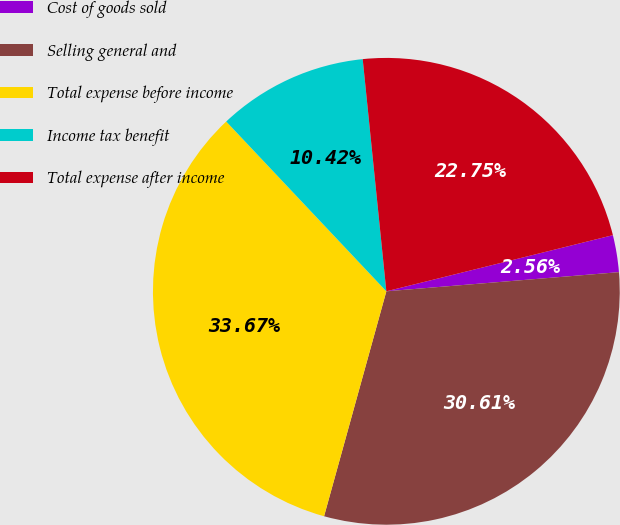Convert chart to OTSL. <chart><loc_0><loc_0><loc_500><loc_500><pie_chart><fcel>Cost of goods sold<fcel>Selling general and<fcel>Total expense before income<fcel>Income tax benefit<fcel>Total expense after income<nl><fcel>2.56%<fcel>30.61%<fcel>33.67%<fcel>10.42%<fcel>22.75%<nl></chart> 